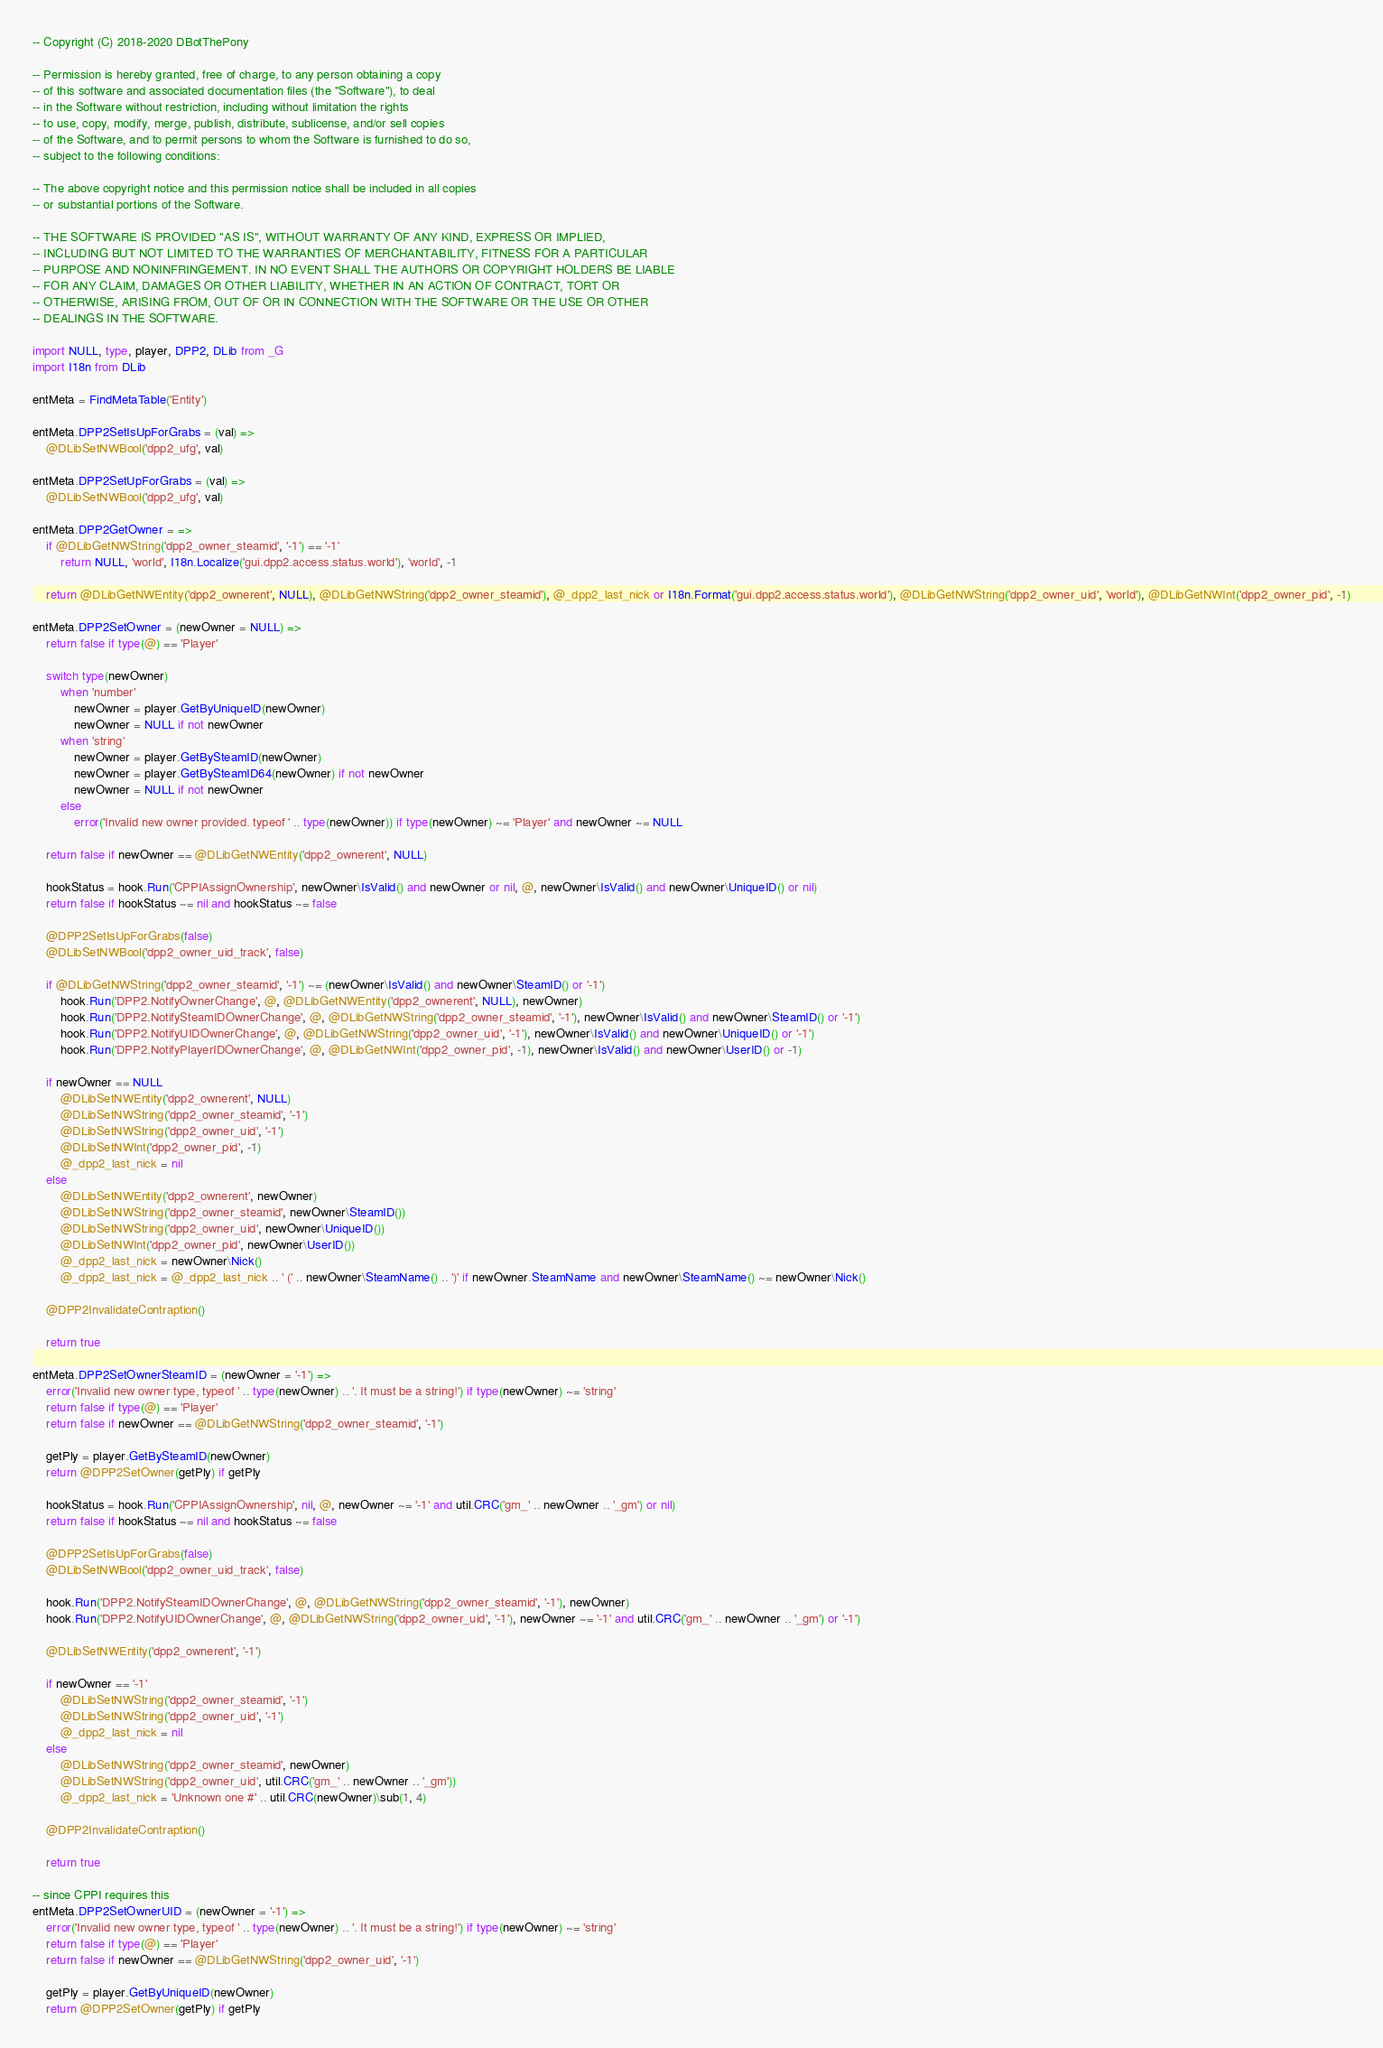<code> <loc_0><loc_0><loc_500><loc_500><_MoonScript_>
-- Copyright (C) 2018-2020 DBotThePony

-- Permission is hereby granted, free of charge, to any person obtaining a copy
-- of this software and associated documentation files (the "Software"), to deal
-- in the Software without restriction, including without limitation the rights
-- to use, copy, modify, merge, publish, distribute, sublicense, and/or sell copies
-- of the Software, and to permit persons to whom the Software is furnished to do so,
-- subject to the following conditions:

-- The above copyright notice and this permission notice shall be included in all copies
-- or substantial portions of the Software.

-- THE SOFTWARE IS PROVIDED "AS IS", WITHOUT WARRANTY OF ANY KIND, EXPRESS OR IMPLIED,
-- INCLUDING BUT NOT LIMITED TO THE WARRANTIES OF MERCHANTABILITY, FITNESS FOR A PARTICULAR
-- PURPOSE AND NONINFRINGEMENT. IN NO EVENT SHALL THE AUTHORS OR COPYRIGHT HOLDERS BE LIABLE
-- FOR ANY CLAIM, DAMAGES OR OTHER LIABILITY, WHETHER IN AN ACTION OF CONTRACT, TORT OR
-- OTHERWISE, ARISING FROM, OUT OF OR IN CONNECTION WITH THE SOFTWARE OR THE USE OR OTHER
-- DEALINGS IN THE SOFTWARE.

import NULL, type, player, DPP2, DLib from _G
import I18n from DLib

entMeta = FindMetaTable('Entity')

entMeta.DPP2SetIsUpForGrabs = (val) =>
	@DLibSetNWBool('dpp2_ufg', val)

entMeta.DPP2SetUpForGrabs = (val) =>
	@DLibSetNWBool('dpp2_ufg', val)

entMeta.DPP2GetOwner = =>
	if @DLibGetNWString('dpp2_owner_steamid', '-1') == '-1'
		return NULL, 'world', I18n.Localize('gui.dpp2.access.status.world'), 'world', -1

	return @DLibGetNWEntity('dpp2_ownerent', NULL), @DLibGetNWString('dpp2_owner_steamid'), @_dpp2_last_nick or I18n.Format('gui.dpp2.access.status.world'), @DLibGetNWString('dpp2_owner_uid', 'world'), @DLibGetNWInt('dpp2_owner_pid', -1)

entMeta.DPP2SetOwner = (newOwner = NULL) =>
	return false if type(@) == 'Player'

	switch type(newOwner)
		when 'number'
			newOwner = player.GetByUniqueID(newOwner)
			newOwner = NULL if not newOwner
		when 'string'
			newOwner = player.GetBySteamID(newOwner)
			newOwner = player.GetBySteamID64(newOwner) if not newOwner
			newOwner = NULL if not newOwner
		else
			error('Invalid new owner provided. typeof ' .. type(newOwner)) if type(newOwner) ~= 'Player' and newOwner ~= NULL

	return false if newOwner == @DLibGetNWEntity('dpp2_ownerent', NULL)

	hookStatus = hook.Run('CPPIAssignOwnership', newOwner\IsValid() and newOwner or nil, @, newOwner\IsValid() and newOwner\UniqueID() or nil)
	return false if hookStatus ~= nil and hookStatus ~= false

	@DPP2SetIsUpForGrabs(false)
	@DLibSetNWBool('dpp2_owner_uid_track', false)

	if @DLibGetNWString('dpp2_owner_steamid', '-1') ~= (newOwner\IsValid() and newOwner\SteamID() or '-1')
		hook.Run('DPP2.NotifyOwnerChange', @, @DLibGetNWEntity('dpp2_ownerent', NULL), newOwner)
		hook.Run('DPP2.NotifySteamIDOwnerChange', @, @DLibGetNWString('dpp2_owner_steamid', '-1'), newOwner\IsValid() and newOwner\SteamID() or '-1')
		hook.Run('DPP2.NotifyUIDOwnerChange', @, @DLibGetNWString('dpp2_owner_uid', '-1'), newOwner\IsValid() and newOwner\UniqueID() or '-1')
		hook.Run('DPP2.NotifyPlayerIDOwnerChange', @, @DLibGetNWInt('dpp2_owner_pid', -1), newOwner\IsValid() and newOwner\UserID() or -1)

	if newOwner == NULL
		@DLibSetNWEntity('dpp2_ownerent', NULL)
		@DLibSetNWString('dpp2_owner_steamid', '-1')
		@DLibSetNWString('dpp2_owner_uid', '-1')
		@DLibSetNWInt('dpp2_owner_pid', -1)
		@_dpp2_last_nick = nil
	else
		@DLibSetNWEntity('dpp2_ownerent', newOwner)
		@DLibSetNWString('dpp2_owner_steamid', newOwner\SteamID())
		@DLibSetNWString('dpp2_owner_uid', newOwner\UniqueID())
		@DLibSetNWInt('dpp2_owner_pid', newOwner\UserID())
		@_dpp2_last_nick = newOwner\Nick()
		@_dpp2_last_nick = @_dpp2_last_nick .. ' (' .. newOwner\SteamName() .. ')' if newOwner.SteamName and newOwner\SteamName() ~= newOwner\Nick()

	@DPP2InvalidateContraption()

	return true

entMeta.DPP2SetOwnerSteamID = (newOwner = '-1') =>
	error('Invalid new owner type, typeof ' .. type(newOwner) .. '. It must be a string!') if type(newOwner) ~= 'string'
	return false if type(@) == 'Player'
	return false if newOwner == @DLibGetNWString('dpp2_owner_steamid', '-1')

	getPly = player.GetBySteamID(newOwner)
	return @DPP2SetOwner(getPly) if getPly

	hookStatus = hook.Run('CPPIAssignOwnership', nil, @, newOwner ~= '-1' and util.CRC('gm_' .. newOwner .. '_gm') or nil)
	return false if hookStatus ~= nil and hookStatus ~= false

	@DPP2SetIsUpForGrabs(false)
	@DLibSetNWBool('dpp2_owner_uid_track', false)

	hook.Run('DPP2.NotifySteamIDOwnerChange', @, @DLibGetNWString('dpp2_owner_steamid', '-1'), newOwner)
	hook.Run('DPP2.NotifyUIDOwnerChange', @, @DLibGetNWString('dpp2_owner_uid', '-1'), newOwner ~= '-1' and util.CRC('gm_' .. newOwner .. '_gm') or '-1')

	@DLibSetNWEntity('dpp2_ownerent', '-1')

	if newOwner == '-1'
		@DLibSetNWString('dpp2_owner_steamid', '-1')
		@DLibSetNWString('dpp2_owner_uid', '-1')
		@_dpp2_last_nick = nil
	else
		@DLibSetNWString('dpp2_owner_steamid', newOwner)
		@DLibSetNWString('dpp2_owner_uid', util.CRC('gm_' .. newOwner .. '_gm'))
		@_dpp2_last_nick = 'Unknown one #' .. util.CRC(newOwner)\sub(1, 4)

	@DPP2InvalidateContraption()

	return true

-- since CPPI requires this
entMeta.DPP2SetOwnerUID = (newOwner = '-1') =>
	error('Invalid new owner type, typeof ' .. type(newOwner) .. '. It must be a string!') if type(newOwner) ~= 'string'
	return false if type(@) == 'Player'
	return false if newOwner == @DLibGetNWString('dpp2_owner_uid', '-1')

	getPly = player.GetByUniqueID(newOwner)
	return @DPP2SetOwner(getPly) if getPly
</code> 